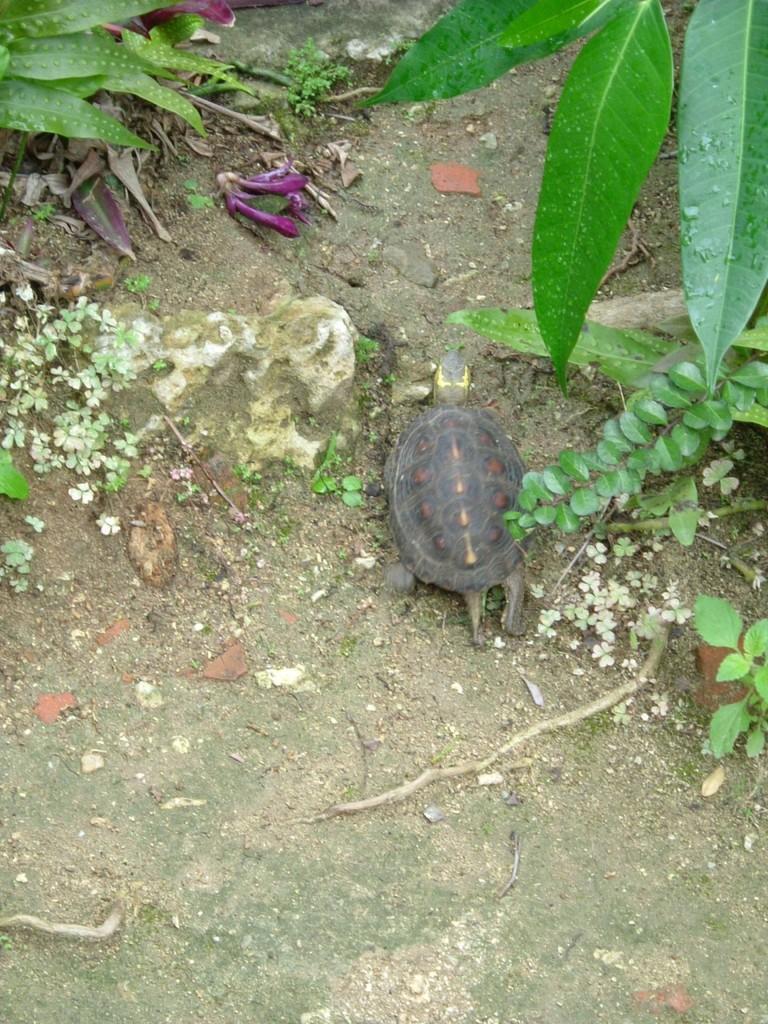Describe this image in one or two sentences. This image contains a tortoise on the land. There are few flowers, leaves and plants are on the land. Right top there are few leaves. 